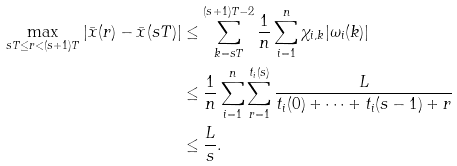<formula> <loc_0><loc_0><loc_500><loc_500>\max _ { s T \leq r < ( s + 1 ) T } | \bar { x } ( r ) - \bar { x } ( s T ) | & \leq \sum ^ { ( s + 1 ) T - 2 } _ { k = s T } \frac { 1 } { n } \sum ^ { n } _ { i = 1 } \chi _ { i , k } | \omega _ { i } ( k ) | \\ & \leq \frac { 1 } { n } \sum ^ { n } _ { i = 1 } \sum ^ { t _ { i } ( s ) } _ { r = 1 } \frac { L } { t _ { i } ( 0 ) + \cdots + t _ { i } ( s - 1 ) + r } \\ & \leq \frac { L } { s } .</formula> 